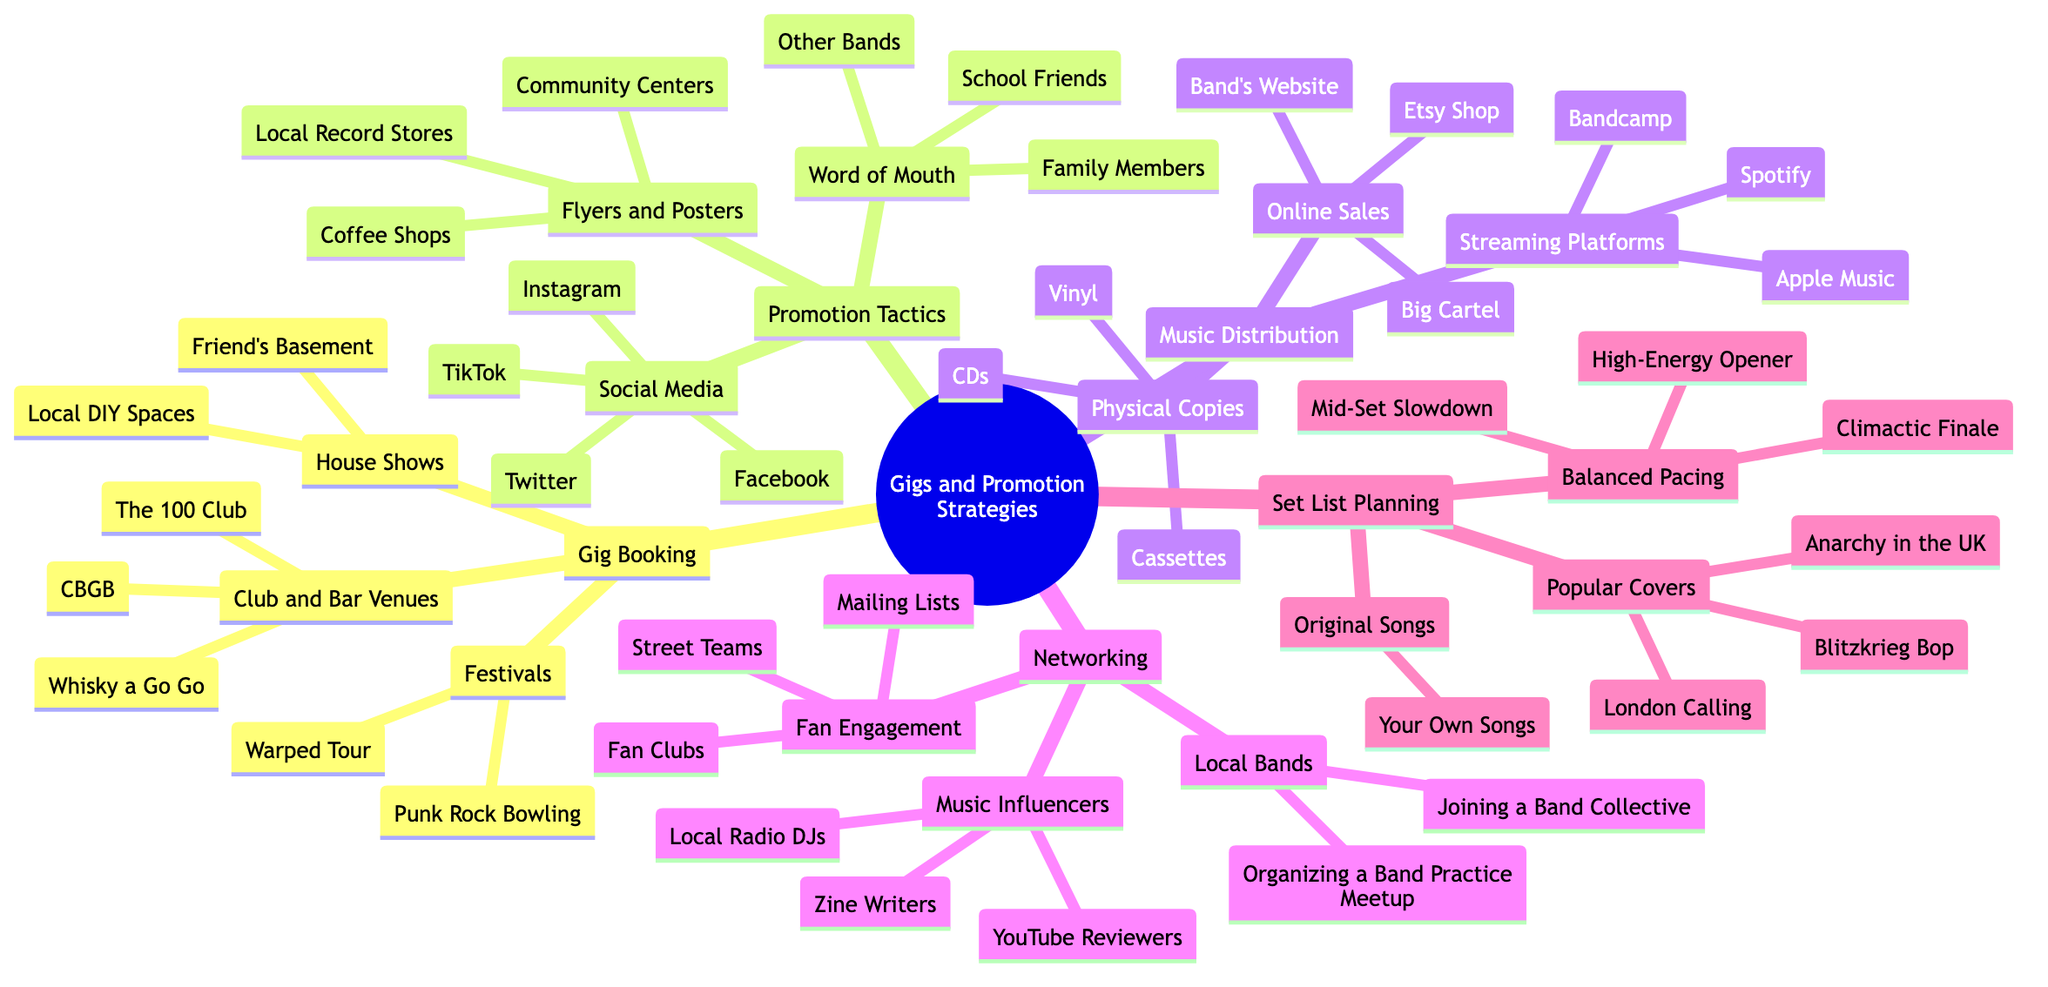What are three venues for gig booking? The "Gig Booking" section lists three categories: "Club and Bar Venues," "House Shows," and "Festivals." Within "Club and Bar Venues," three specific venues are mentioned: "The 100 Club," "CBGB," and "Whisky a Go Go."
Answer: The 100 Club, CBGB, Whisky a Go Go How many promotion tactics are shown? Under "Promotion Tactics," there are three main strategies: "Social Media," "Flyers and Posters," and "Word of Mouth." Therefore, the total number of promotion tactics is three.
Answer: 3 What is one method for music distribution? The "Music Distribution" section includes three subcategories: "Streaming Platforms," "Physical Copies," and "Online Sales." Any item mentioned within these subcategories could be counted as a method. For example, "Spotify" is found under "Streaming Platforms."
Answer: Spotify Which gig booking method involves bringing an audience to a private space? The "House Shows" category under "Gig Booking" is directly about hosting gigs in private spaces, which typically involves inviting an audience to a friend's basement or local DIY spaces.
Answer: House Shows What is a tactic that involves personal connections? "Word of Mouth" is a promotion tactic that inherently relies on personal connections, as it mentions "School Friends," "Family Members," and "Other Bands" in its subcategory.
Answer: Word of Mouth Name one popular cover listed in the set list planning. In the "Set List Planning" section, "Popular Covers" includes three specific songs: "Blitzkrieg Bop," "London Calling," and "Anarchy in the UK." Any of these could be considered a popular cover song. For instance, "Blitzkrieg Bop" is one of them.
Answer: Blitzkrieg Bop What are two ways to engage with fans? The "Fan Engagement" section under "Networking" suggests three methods: "Street Teams," "Fan Clubs," and "Mailing Lists." Choosing any two of these would answer the question. For example, "Street Teams" and "Fan Clubs" can be mentioned.
Answer: Street Teams, Fan Clubs How does networking benefit local bands? In the "Networking" section, the focus is on building relationships with "Local Bands," "Music Influencers," and "Fan Engagement." Joining a band collective or organizing meetups helps local bands connect and collaborate, which illustrates the benefit clearly.
Answer: Networking 